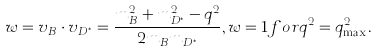<formula> <loc_0><loc_0><loc_500><loc_500>w = v _ { B } \cdot v _ { D ^ { \ast } } = \frac { m _ { B } ^ { 2 } + m _ { D ^ { \ast } } ^ { 2 } - q ^ { 2 } } { 2 m _ { B } m _ { D ^ { \ast } } } , w = 1 f o r q ^ { 2 } = q _ { \max } ^ { 2 } .</formula> 